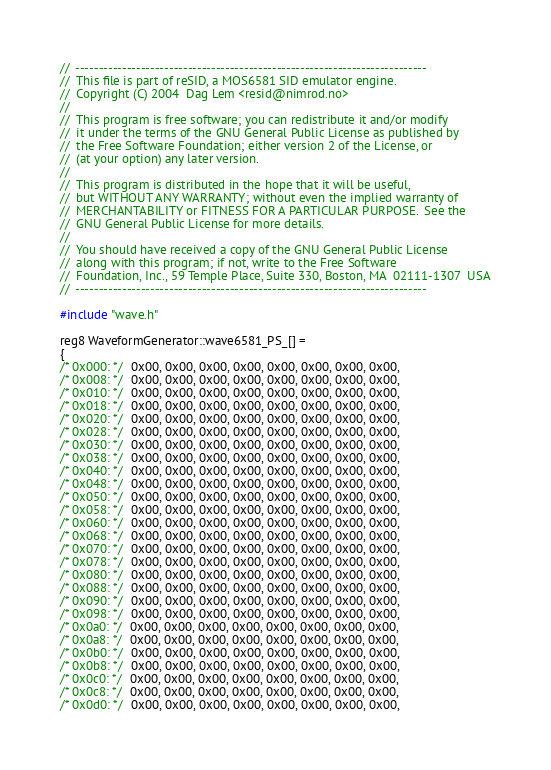<code> <loc_0><loc_0><loc_500><loc_500><_C++_>//  ---------------------------------------------------------------------------
//  This file is part of reSID, a MOS6581 SID emulator engine.
//  Copyright (C) 2004  Dag Lem <resid@nimrod.no>
//
//  This program is free software; you can redistribute it and/or modify
//  it under the terms of the GNU General Public License as published by
//  the Free Software Foundation; either version 2 of the License, or
//  (at your option) any later version.
//
//  This program is distributed in the hope that it will be useful,
//  but WITHOUT ANY WARRANTY; without even the implied warranty of
//  MERCHANTABILITY or FITNESS FOR A PARTICULAR PURPOSE.  See the
//  GNU General Public License for more details.
//
//  You should have received a copy of the GNU General Public License
//  along with this program; if not, write to the Free Software
//  Foundation, Inc., 59 Temple Place, Suite 330, Boston, MA  02111-1307  USA
//  ---------------------------------------------------------------------------

#include "wave.h"

reg8 WaveformGenerator::wave6581_PS_[] =
{
/* 0x000: */  0x00, 0x00, 0x00, 0x00, 0x00, 0x00, 0x00, 0x00,
/* 0x008: */  0x00, 0x00, 0x00, 0x00, 0x00, 0x00, 0x00, 0x00,
/* 0x010: */  0x00, 0x00, 0x00, 0x00, 0x00, 0x00, 0x00, 0x00,
/* 0x018: */  0x00, 0x00, 0x00, 0x00, 0x00, 0x00, 0x00, 0x00,
/* 0x020: */  0x00, 0x00, 0x00, 0x00, 0x00, 0x00, 0x00, 0x00,
/* 0x028: */  0x00, 0x00, 0x00, 0x00, 0x00, 0x00, 0x00, 0x00,
/* 0x030: */  0x00, 0x00, 0x00, 0x00, 0x00, 0x00, 0x00, 0x00,
/* 0x038: */  0x00, 0x00, 0x00, 0x00, 0x00, 0x00, 0x00, 0x00,
/* 0x040: */  0x00, 0x00, 0x00, 0x00, 0x00, 0x00, 0x00, 0x00,
/* 0x048: */  0x00, 0x00, 0x00, 0x00, 0x00, 0x00, 0x00, 0x00,
/* 0x050: */  0x00, 0x00, 0x00, 0x00, 0x00, 0x00, 0x00, 0x00,
/* 0x058: */  0x00, 0x00, 0x00, 0x00, 0x00, 0x00, 0x00, 0x00,
/* 0x060: */  0x00, 0x00, 0x00, 0x00, 0x00, 0x00, 0x00, 0x00,
/* 0x068: */  0x00, 0x00, 0x00, 0x00, 0x00, 0x00, 0x00, 0x00,
/* 0x070: */  0x00, 0x00, 0x00, 0x00, 0x00, 0x00, 0x00, 0x00,
/* 0x078: */  0x00, 0x00, 0x00, 0x00, 0x00, 0x00, 0x00, 0x00,
/* 0x080: */  0x00, 0x00, 0x00, 0x00, 0x00, 0x00, 0x00, 0x00,
/* 0x088: */  0x00, 0x00, 0x00, 0x00, 0x00, 0x00, 0x00, 0x00,
/* 0x090: */  0x00, 0x00, 0x00, 0x00, 0x00, 0x00, 0x00, 0x00,
/* 0x098: */  0x00, 0x00, 0x00, 0x00, 0x00, 0x00, 0x00, 0x00,
/* 0x0a0: */  0x00, 0x00, 0x00, 0x00, 0x00, 0x00, 0x00, 0x00,
/* 0x0a8: */  0x00, 0x00, 0x00, 0x00, 0x00, 0x00, 0x00, 0x00,
/* 0x0b0: */  0x00, 0x00, 0x00, 0x00, 0x00, 0x00, 0x00, 0x00,
/* 0x0b8: */  0x00, 0x00, 0x00, 0x00, 0x00, 0x00, 0x00, 0x00,
/* 0x0c0: */  0x00, 0x00, 0x00, 0x00, 0x00, 0x00, 0x00, 0x00,
/* 0x0c8: */  0x00, 0x00, 0x00, 0x00, 0x00, 0x00, 0x00, 0x00,
/* 0x0d0: */  0x00, 0x00, 0x00, 0x00, 0x00, 0x00, 0x00, 0x00,</code> 